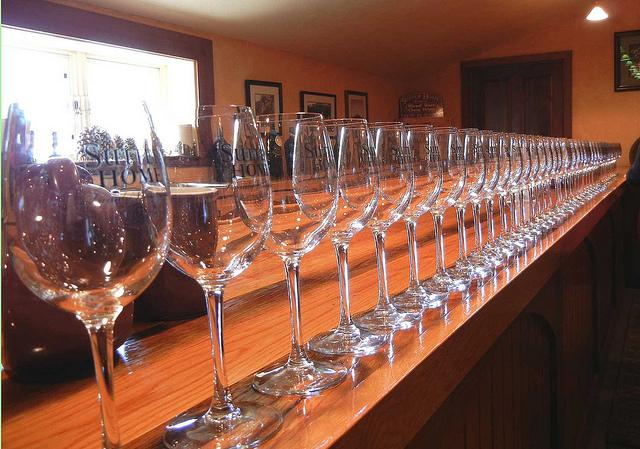What is lined up next to each other?

Choices:
A) babies
B) eggs
C) wine glasses
D) pumpkins wine glasses 